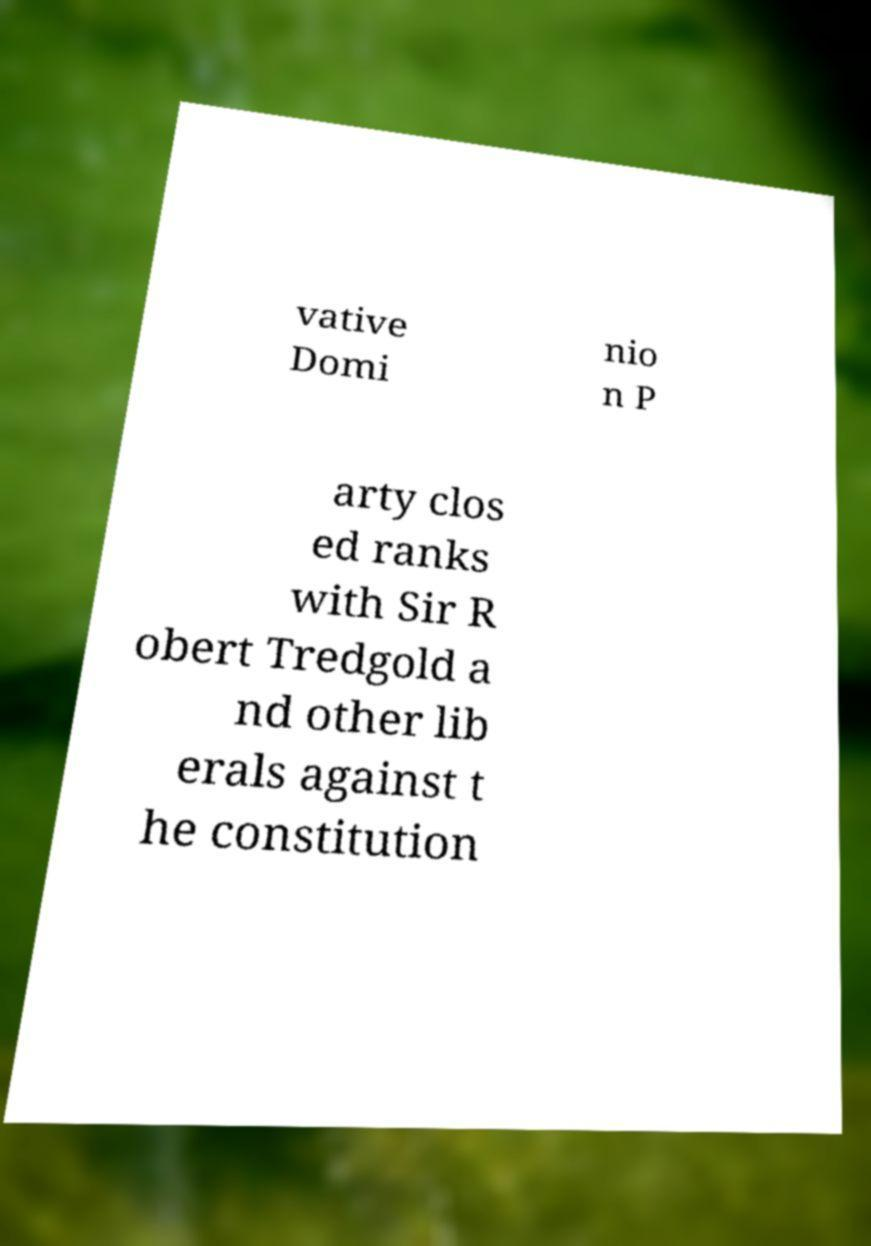For documentation purposes, I need the text within this image transcribed. Could you provide that? vative Domi nio n P arty clos ed ranks with Sir R obert Tredgold a nd other lib erals against t he constitution 